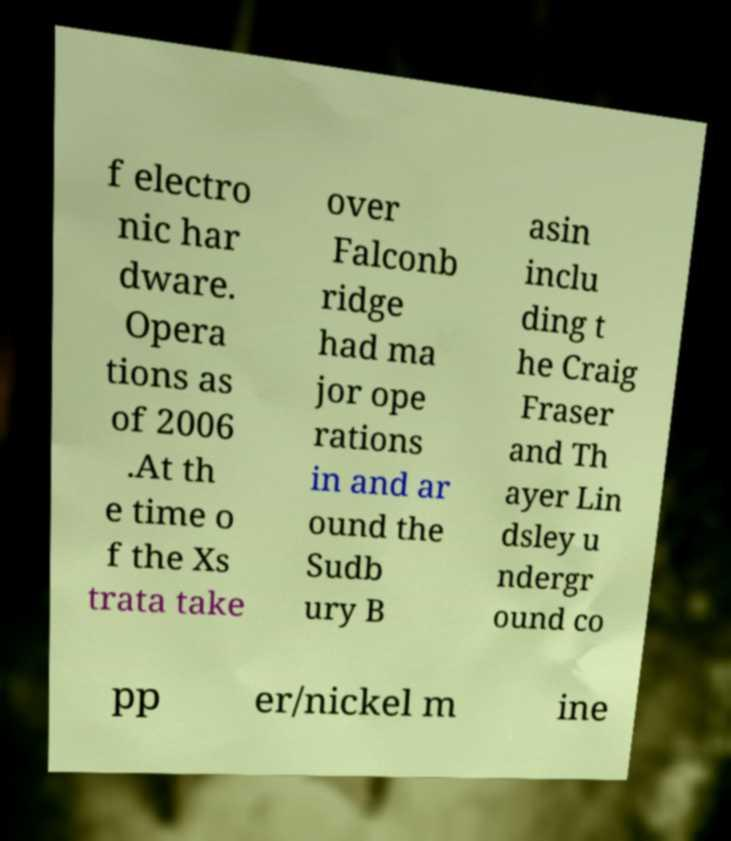There's text embedded in this image that I need extracted. Can you transcribe it verbatim? f electro nic har dware. Opera tions as of 2006 .At th e time o f the Xs trata take over Falconb ridge had ma jor ope rations in and ar ound the Sudb ury B asin inclu ding t he Craig Fraser and Th ayer Lin dsley u ndergr ound co pp er/nickel m ine 